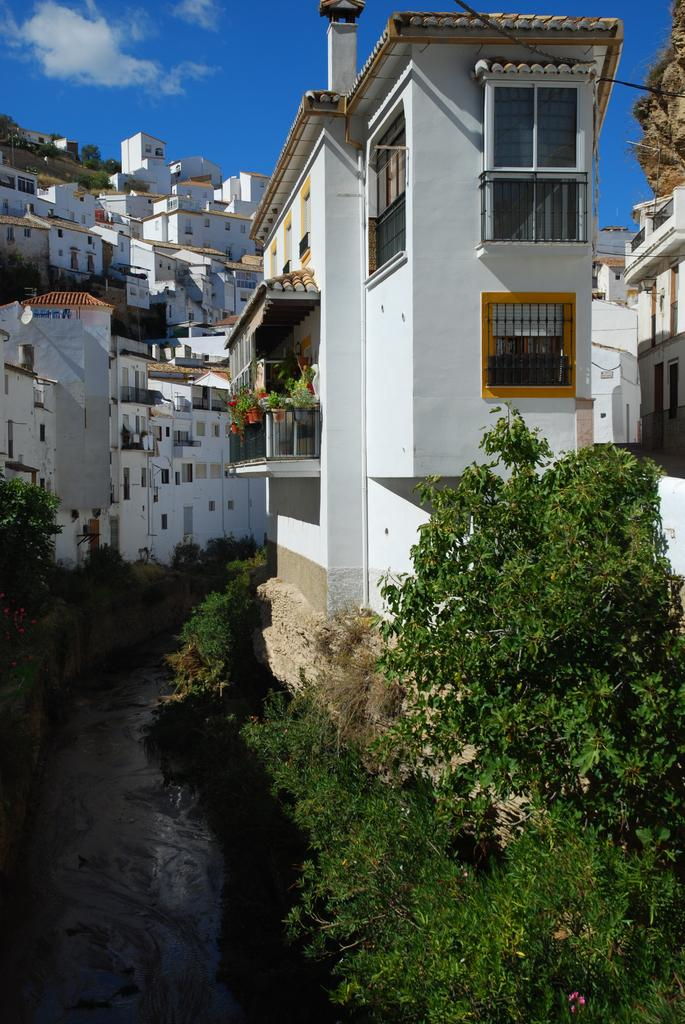What type of vegetation can be seen in the image? There are trees and plants visible in the image. What natural element is present in the image? There is water visible in the image. What type of man-made structures are in the image? There are buildings in the image. What geographical feature can be seen in the image? There is a hill in the image. What is visible in the sky in the image? The sky is visible in the image, and clouds are present. What type of pie is being cut with the scissors in the image? There is no pie or scissors present in the image. What year does the image depict? The image does not depict a specific year; it is a snapshot of a scene that could occur at any time. 